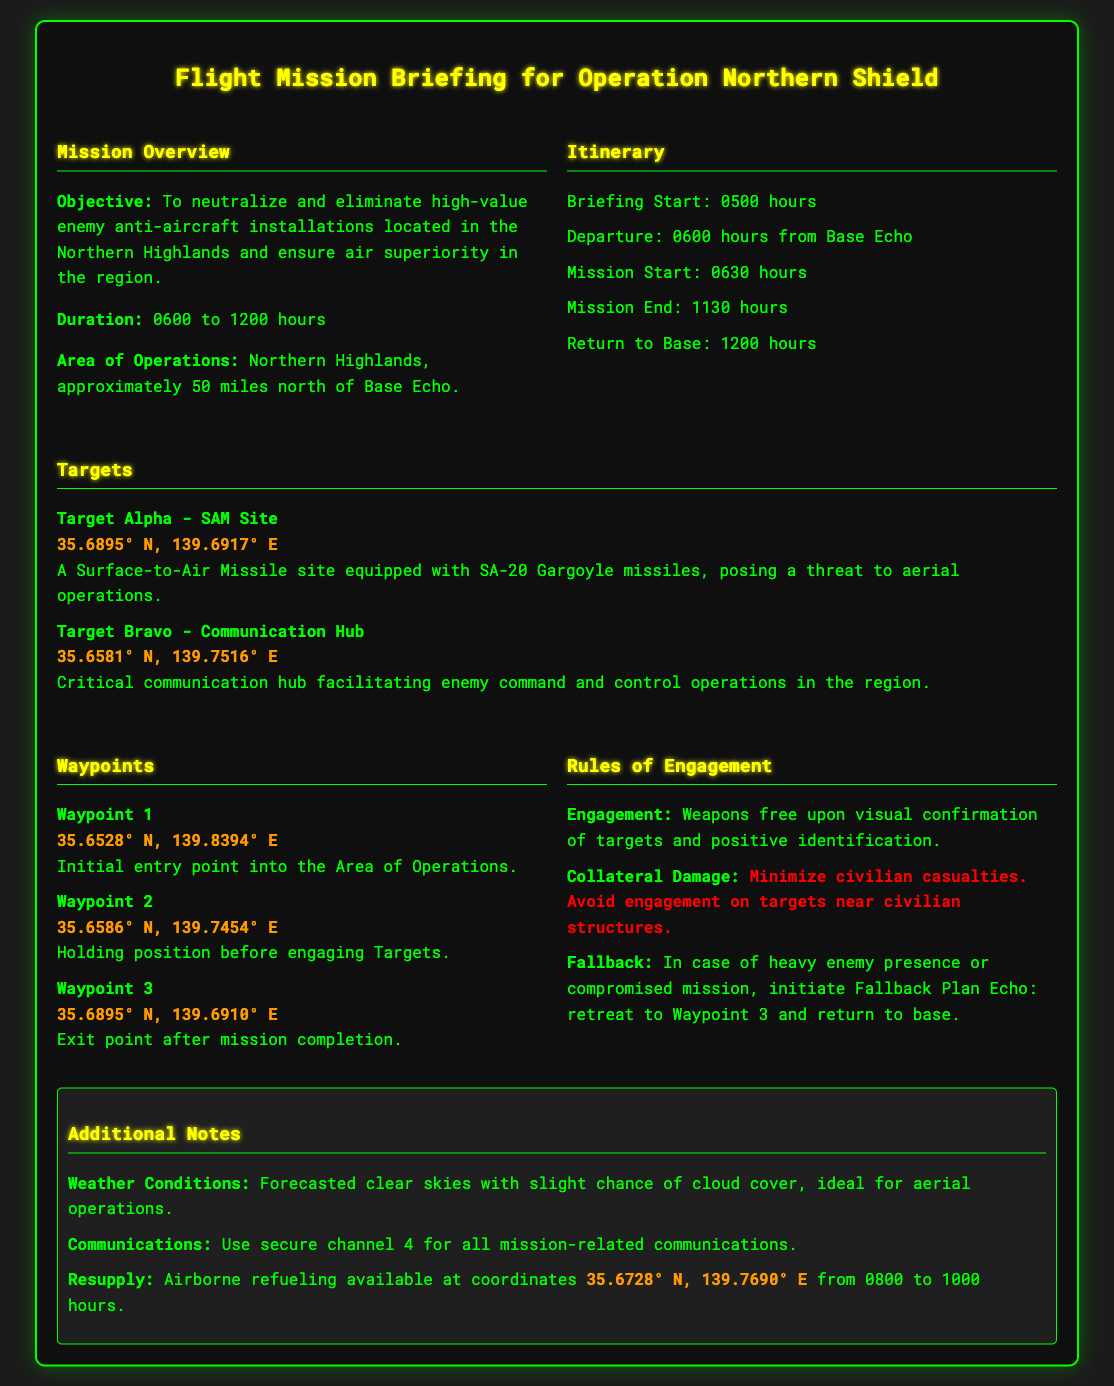What is the objective of the mission? The objective is stated in the mission overview section, focusing on the neutralization of enemy installations.
Answer: Neutralize and eliminate high-value enemy anti-aircraft installations What time does the mission start? The mission start time is listed in the itinerary section of the document.
Answer: 0630 hours What is the location of Target Bravo? The coordinates for Target Bravo can be found in the targets section of the document.
Answer: 35.6581° N, 139.7516° E What are the weather conditions forecasted for the mission? The weather conditions are mentioned in the additional notes section, indicating the clarity of the skies.
Answer: Clear skies What is the fallback plan in case of heavy enemy presence? The fallback plan is defined in the rules of engagement section, outlining the action to be taken if the mission is compromised.
Answer: Fallback Plan Echo How long is the duration of the operation? The duration is specified in the mission overview, indicating the time frame from start to end.
Answer: 6 hours Where is the airborne refueling available? The coordinates for airborne refueling are provided in the additional notes section of the document.
Answer: 35.6728° N, 139.7690° E What is the return time to base? The return time to base is outlined in the itinerary section of the document.
Answer: 1200 hours What is the warning regarding collateral damage? The rules of engagement section contains information about minimizing civilian casualties and avoiding engagements near civilian structures.
Answer: Minimize civilian casualties 